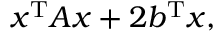Convert formula to latex. <formula><loc_0><loc_0><loc_500><loc_500>x ^ { T } A x + 2 b ^ { T } x ,</formula> 